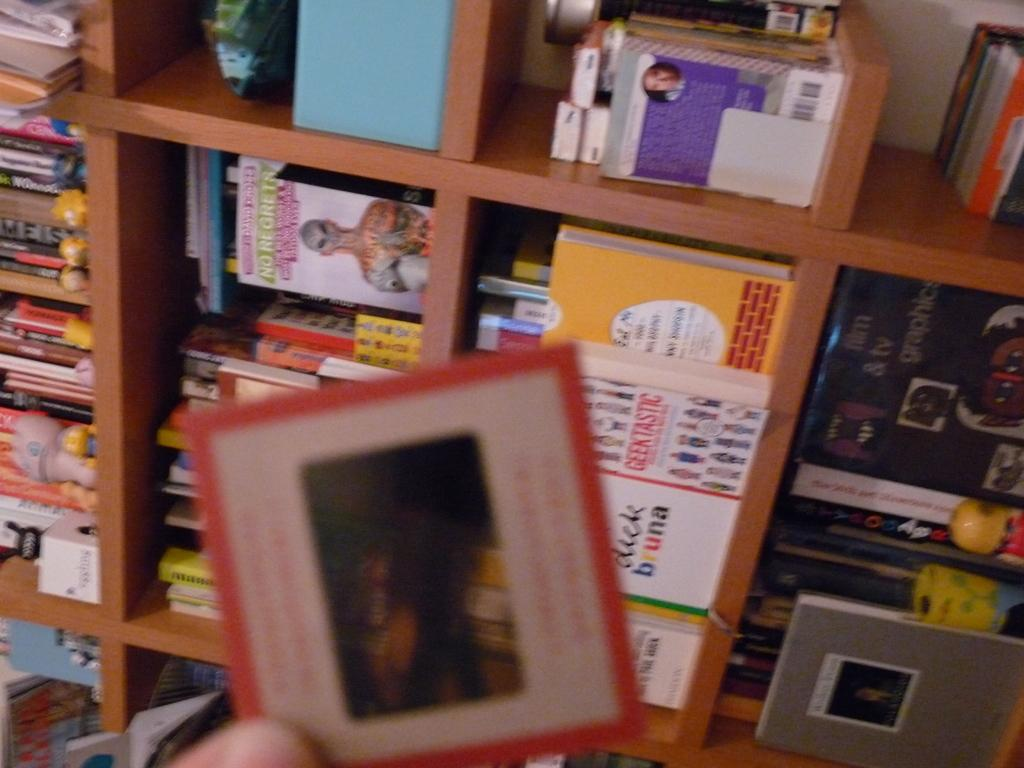Provide a one-sentence caption for the provided image. A person is holding up a card in front of a book shelf with a book by Dick Bruna. 